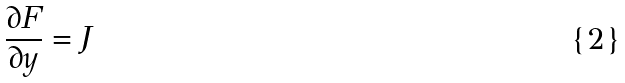<formula> <loc_0><loc_0><loc_500><loc_500>\frac { \partial F } { \partial y } = J</formula> 